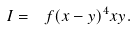<formula> <loc_0><loc_0><loc_500><loc_500>I = \ f { ( x - y ) ^ { 4 } } { x y } .</formula> 